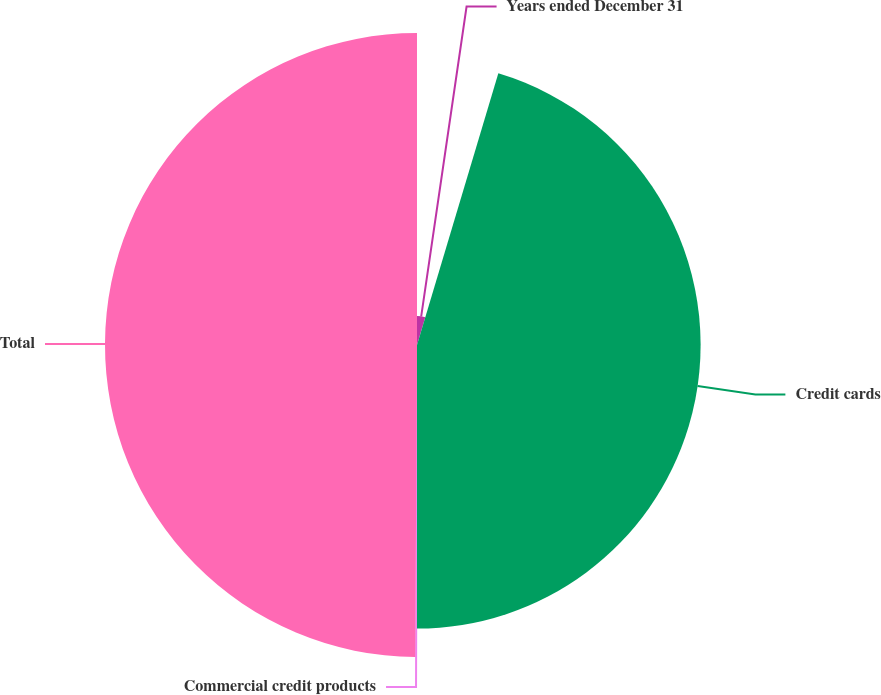<chart> <loc_0><loc_0><loc_500><loc_500><pie_chart><fcel>Years ended December 31<fcel>Credit cards<fcel>Commercial credit products<fcel>Total<nl><fcel>4.63%<fcel>45.37%<fcel>0.09%<fcel>49.91%<nl></chart> 